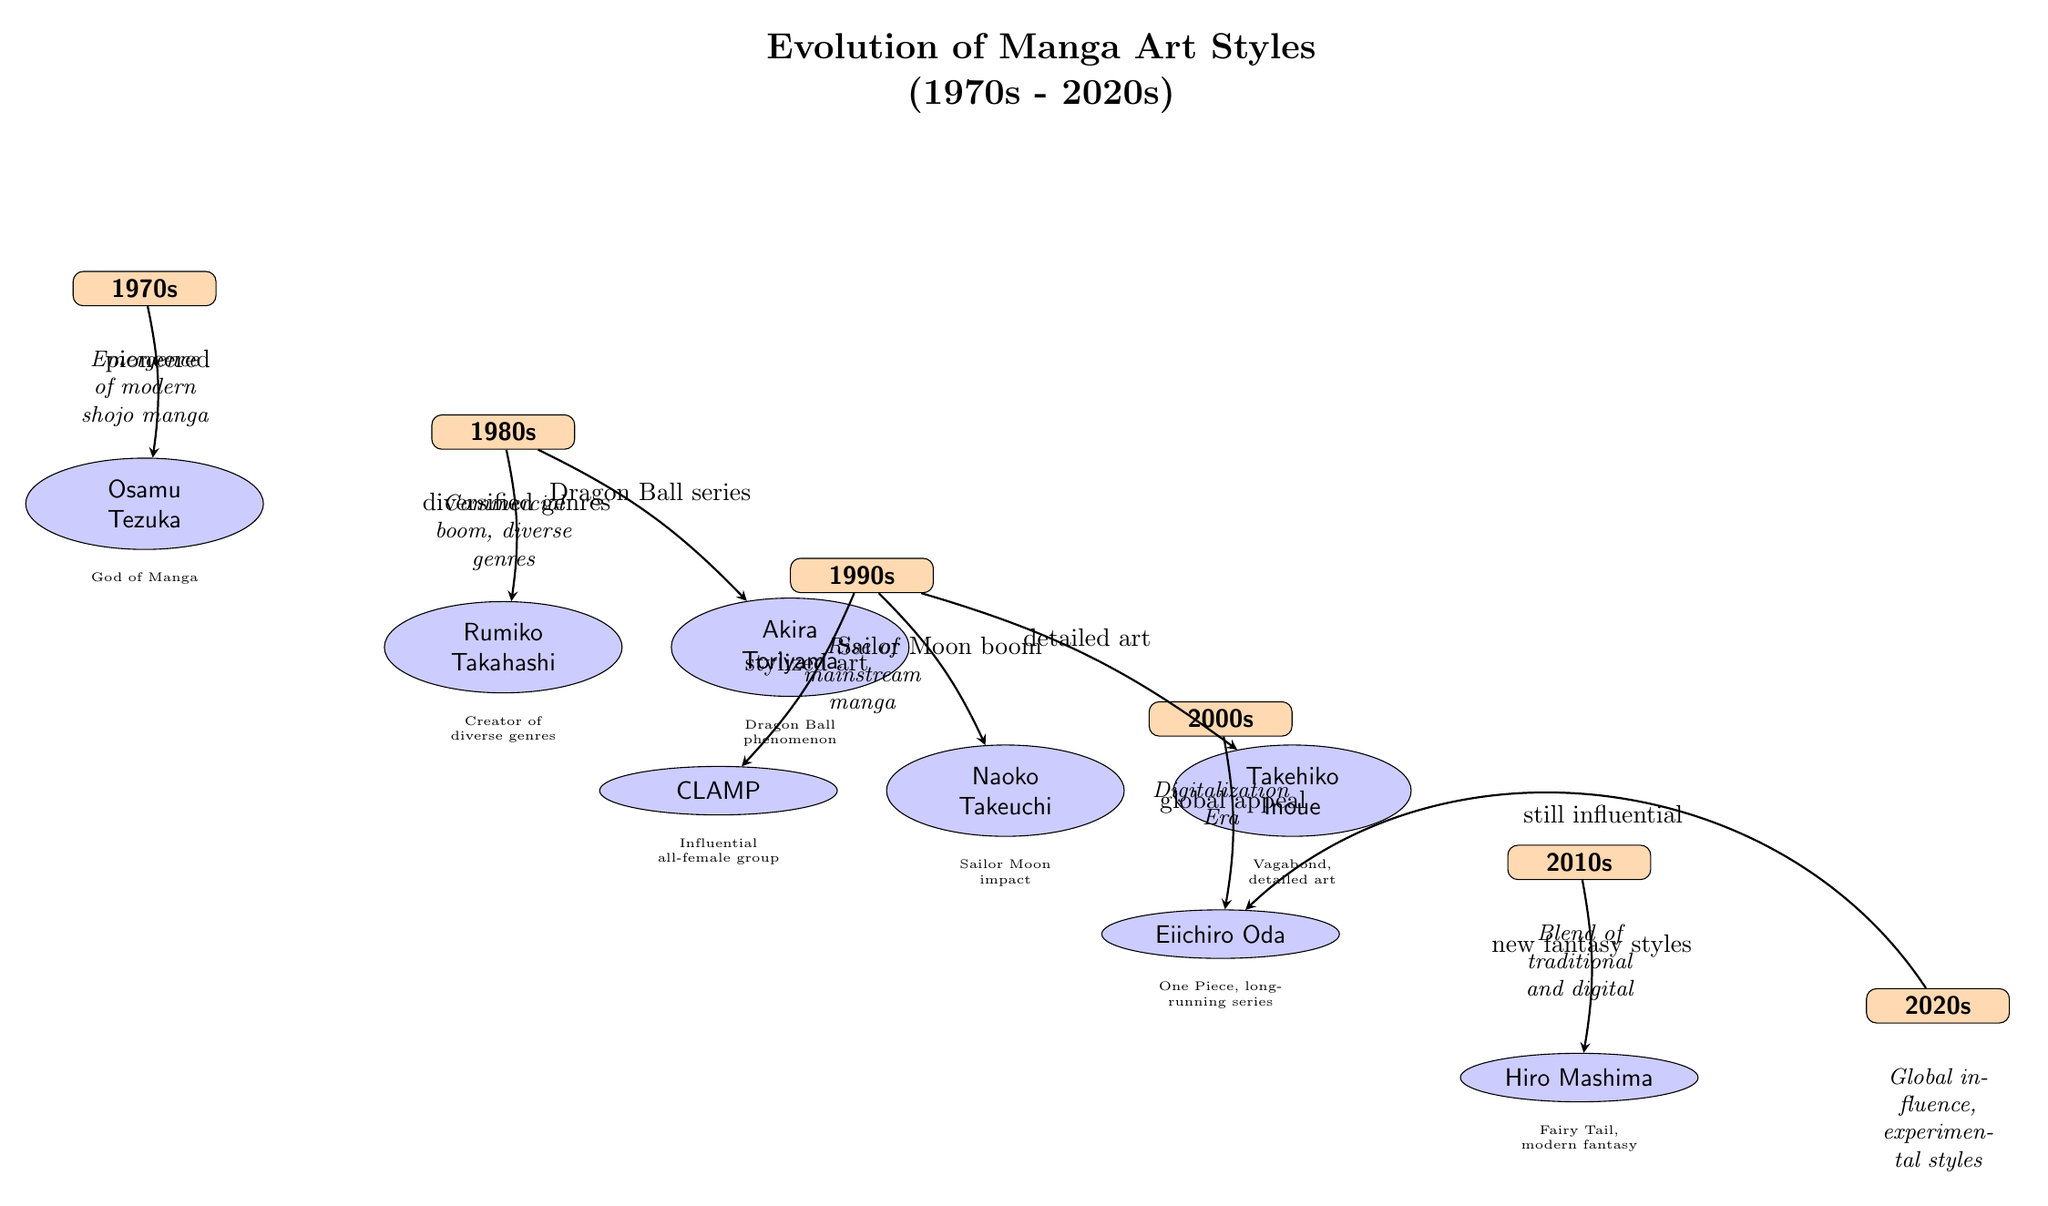What decade is represented by the artist Osamu Tezuka? Osamu Tezuka is positioned directly below the 1970s node, indicating that he represents the manga art style of this decade.
Answer: 1970s Which artist is associated with the Dragon Ball series? The arrow from the 1980s decade to Akira Toriyama indicates that he is the artist responsible for the Dragon Ball series, which is also mentioned in the description of the arrow.
Answer: Akira Toriyama How many artists are mentioned in the diagram? Counting the number of artist nodes shown (Osamu Tezuka, Rumiko Takahashi, Akira Toriyama, CLAMP, Naoko Takeuchi, Takehiko Inoue, Eiichiro Oda, Hiro Mashima), there are a total of eight artists represented in the diagram.
Answer: 8 What is the main influence of CLAMP in the 1990s? The arrow pointing from the 1990s decade to CLAMP is labeled "stylized art," indicating that their influence in this decade is primarily characterized by stylized art styles.
Answer: stylized art Which decade saw the emergence of the digitalization era in manga? The description located below the 2000s node indicates that this decade is specifically associated with the Digitalization Era in the evolution of manga art styles.
Answer: 2000s What was the significant impact of Naoko Takeuchi in the 1990s? The arrow directed from the 1990s to Naoko Takeuchi indicates that the "Sailor Moon boom" is her significant impact, as described on the arrow's label.
Answer: Sailor Moon boom Which artist is linked to the creation of Fairy Tail? The artist node labeled Hiro Mashima, connected with the 2010s decade, is identified as the creator of Fairy Tail, according to the description below his artist node.
Answer: Hiro Mashima What influence does Eiichiro Oda continue to have in the 2020s? The diagram shows an arrow from the 2020s decade bending towards Eiichiro Oda, indicating that he remains influential, even in the current decade.
Answer: still influential Which duo of artists is connected to the 1980s decade? The 1980s decade is enjoined with the artists Rumiko Takahashi and Akira Toriyama, showing a diversification of genres and a specific highlight on the Dragon Ball series, respectively.
Answer: Rumiko Takahashi and Akira Toriyama 